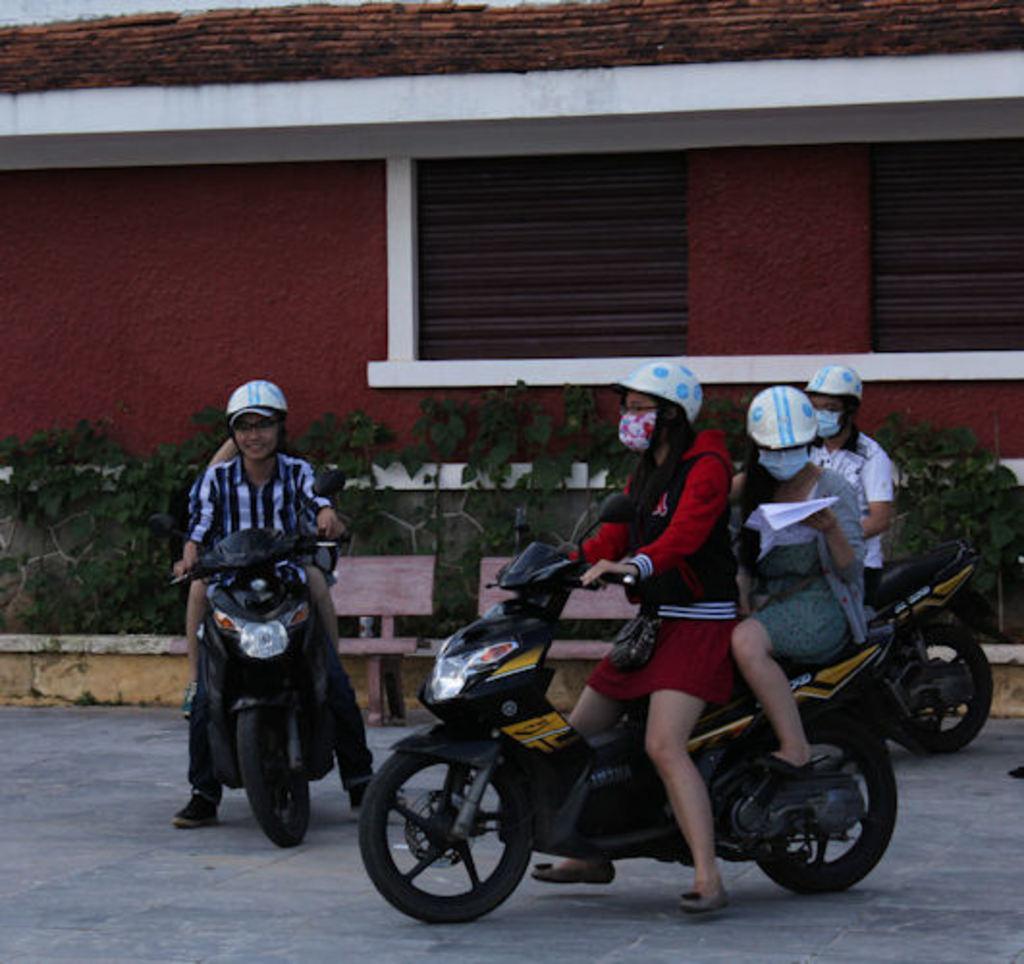Can you describe this image briefly? As we can see in the image, there are four people sitting on motorcycles. Behind them there is a red color house. In front of the house there are few plants and two benches. 